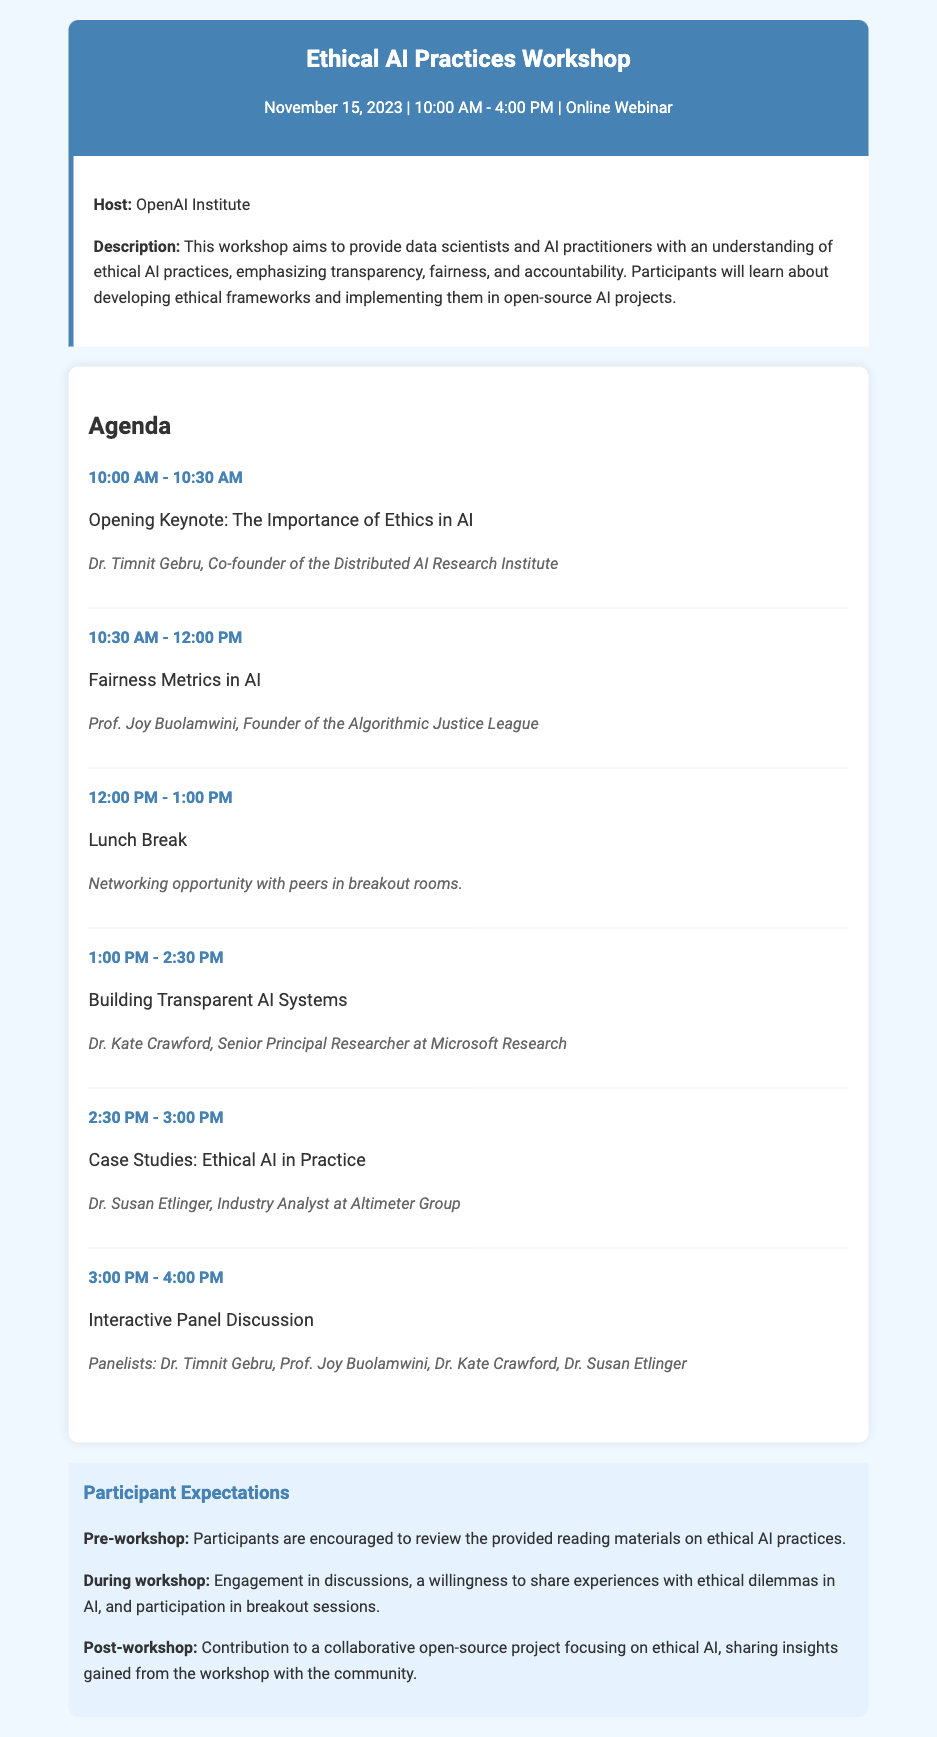what is the date of the workshop? The date of the workshop is provided in the header section of the document.
Answer: November 15, 2023 who is the host of the workshop? The host is mentioned in the workshop info section.
Answer: OpenAI Institute what time does the workshop start? The start time is listed in the header section.
Answer: 10:00 AM who is the speaker for the opening keynote? The speaker's name is mentioned in the agenda under the opening keynote session.
Answer: Dr. Timnit Gebru how long is the lunch break scheduled for? The length of the lunch break is specified in the agenda.
Answer: 1 hour what is one expectation for participants during the workshop? Participants' expectations during the workshop can be found in the expectations section.
Answer: Engagement in discussions how many speakers will participate in the interactive panel discussion? The number of speakers is mentioned when listing the panelists in the agenda.
Answer: Four what is the focus of the workshop as described? The focus is outlined in the description of the workshop in the workshop info section.
Answer: Ethical AI practices what kind of project are participants encouraged to contribute to post-workshop? The type of project is mentioned in the post-workshop expectations.
Answer: Collaborative open-source project 